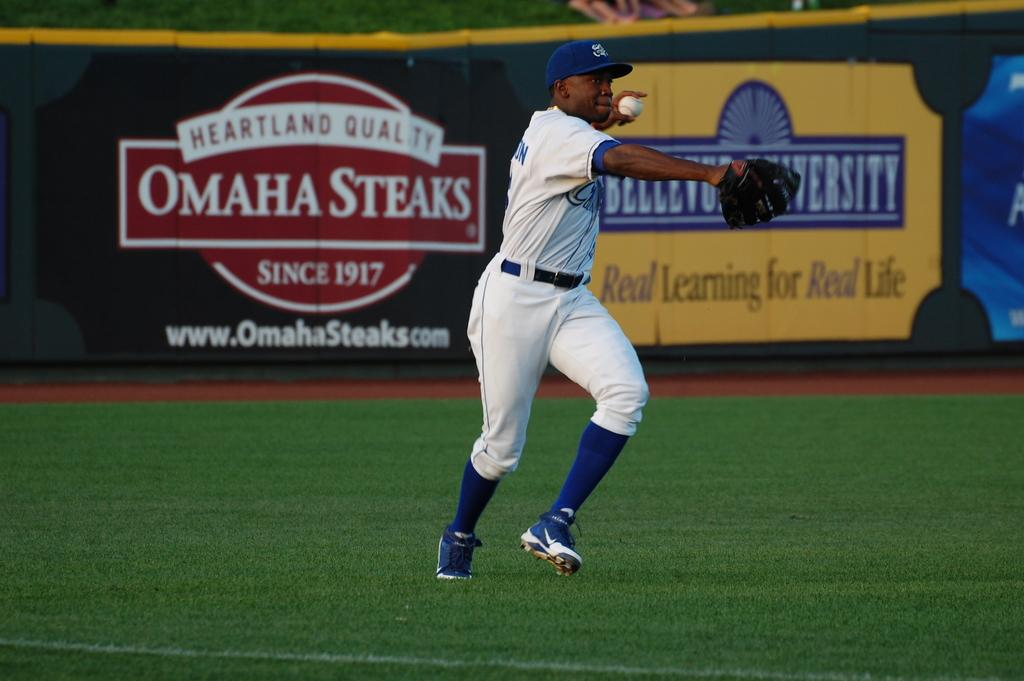<image>
Summarize the visual content of the image. the name Omaha is on an ad on the outfield wall 